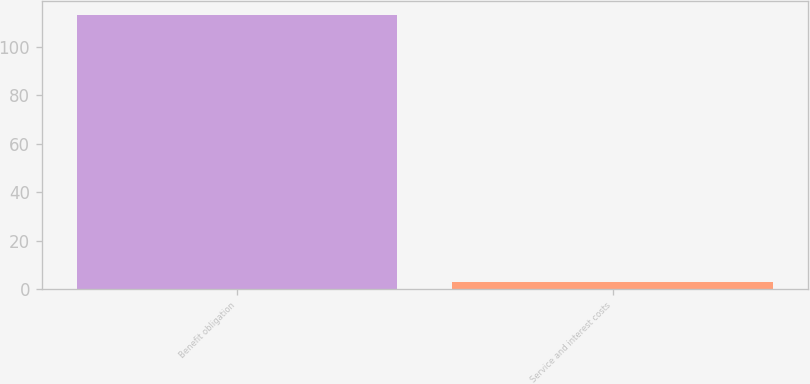<chart> <loc_0><loc_0><loc_500><loc_500><bar_chart><fcel>Benefit obligation<fcel>Service and interest costs<nl><fcel>113<fcel>3<nl></chart> 